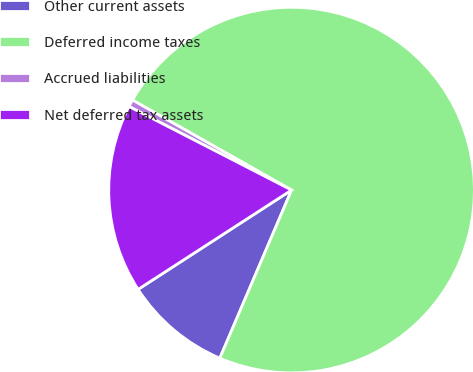Convert chart to OTSL. <chart><loc_0><loc_0><loc_500><loc_500><pie_chart><fcel>Other current assets<fcel>Deferred income taxes<fcel>Accrued liabilities<fcel>Net deferred tax assets<nl><fcel>9.44%<fcel>73.23%<fcel>0.64%<fcel>16.7%<nl></chart> 